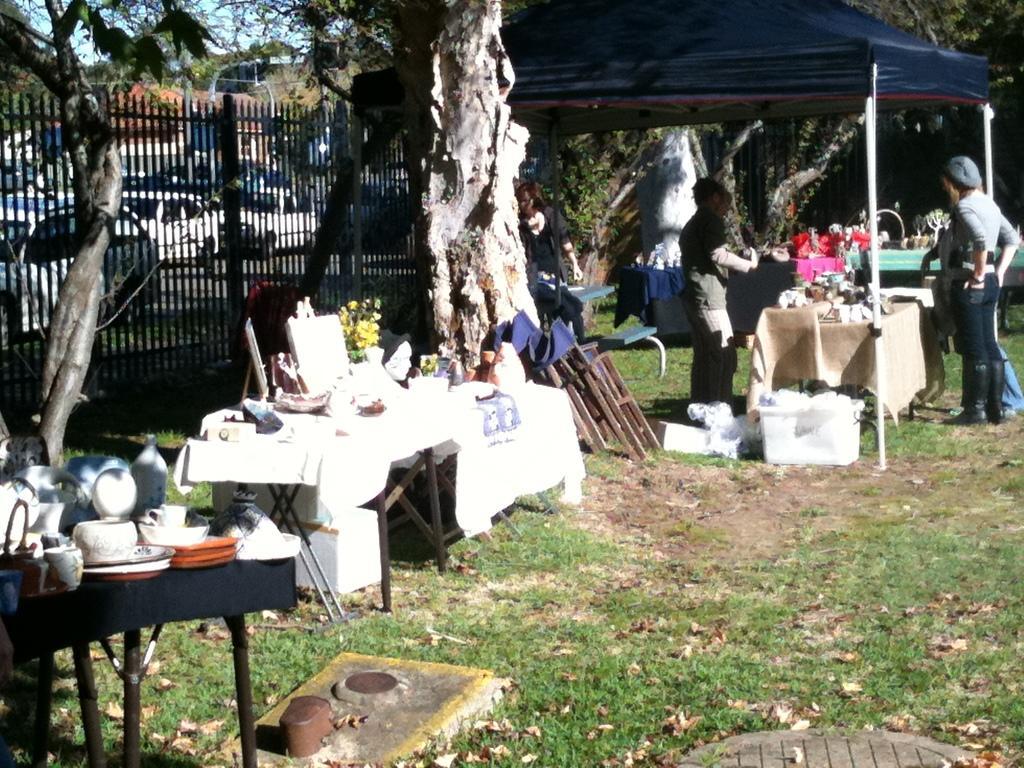In one or two sentences, can you explain what this image depicts? In this Image I see 3 persons who are standing on the path and there are tables on which there are many things and I can also see the trees in the background. I see the fence and many vehicles on the road. 